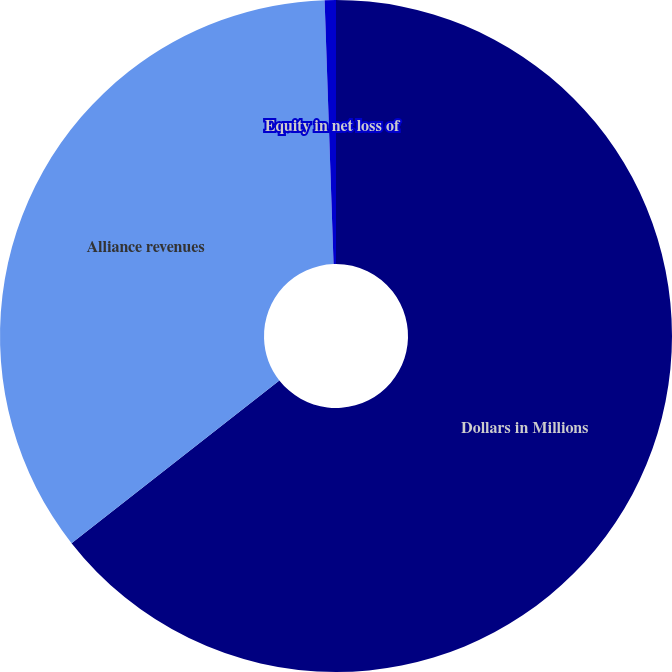Convert chart to OTSL. <chart><loc_0><loc_0><loc_500><loc_500><pie_chart><fcel>Dollars in Millions<fcel>Alliance revenues<fcel>Equity in net loss of<nl><fcel>64.42%<fcel>35.04%<fcel>0.54%<nl></chart> 